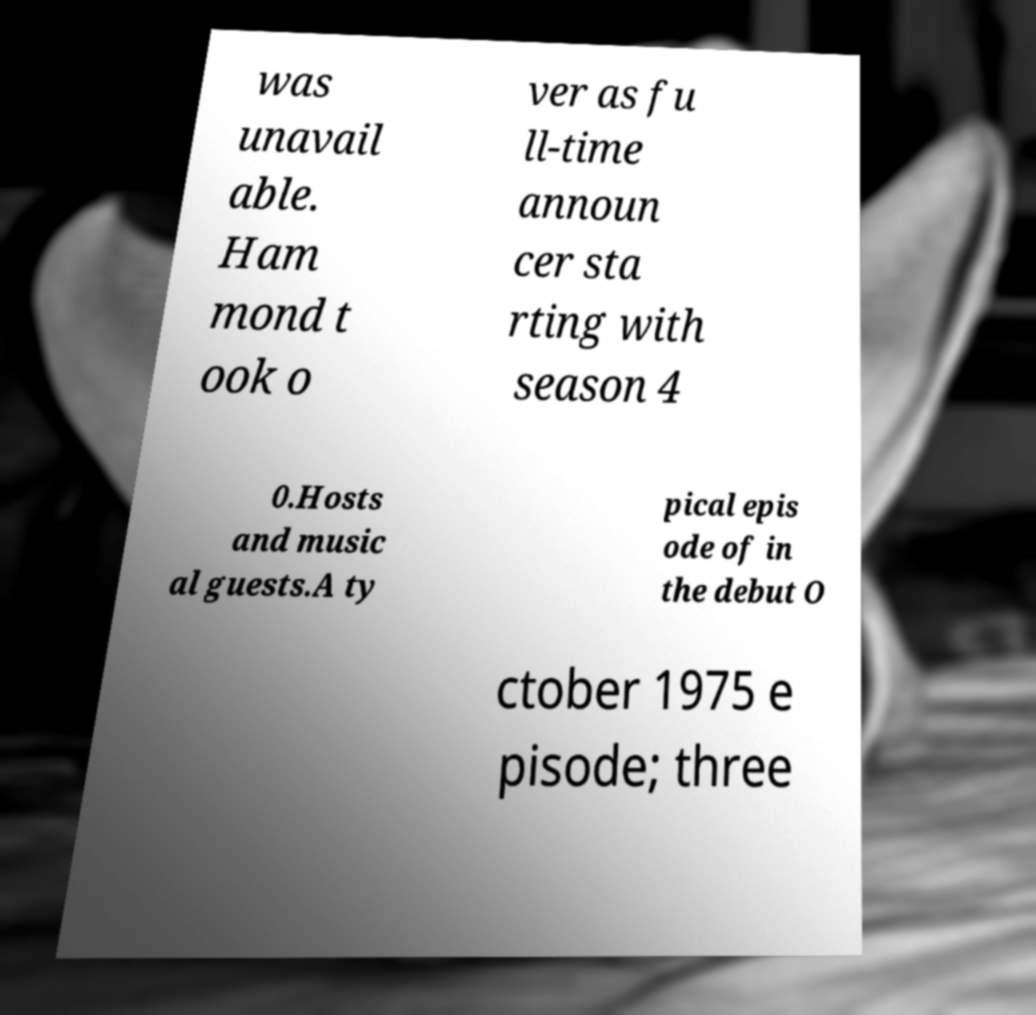There's text embedded in this image that I need extracted. Can you transcribe it verbatim? was unavail able. Ham mond t ook o ver as fu ll-time announ cer sta rting with season 4 0.Hosts and music al guests.A ty pical epis ode of in the debut O ctober 1975 e pisode; three 